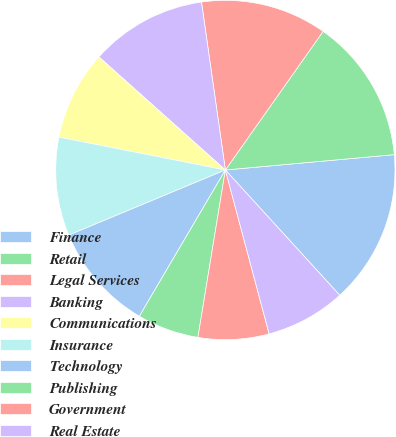<chart> <loc_0><loc_0><loc_500><loc_500><pie_chart><fcel>Finance<fcel>Retail<fcel>Legal Services<fcel>Banking<fcel>Communications<fcel>Insurance<fcel>Technology<fcel>Publishing<fcel>Government<fcel>Real Estate<nl><fcel>14.66%<fcel>13.78%<fcel>12.02%<fcel>11.14%<fcel>8.5%<fcel>9.38%<fcel>10.26%<fcel>5.87%<fcel>6.74%<fcel>7.62%<nl></chart> 